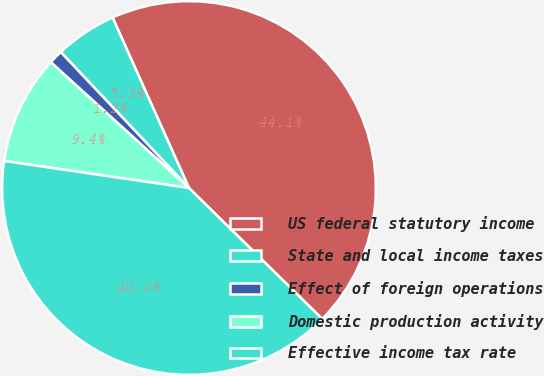Convert chart to OTSL. <chart><loc_0><loc_0><loc_500><loc_500><pie_chart><fcel>US federal statutory income<fcel>State and local income taxes<fcel>Effect of foreign operations<fcel>Domestic production activity<fcel>Effective income tax rate<nl><fcel>44.07%<fcel>5.33%<fcel>1.21%<fcel>9.44%<fcel>39.95%<nl></chart> 